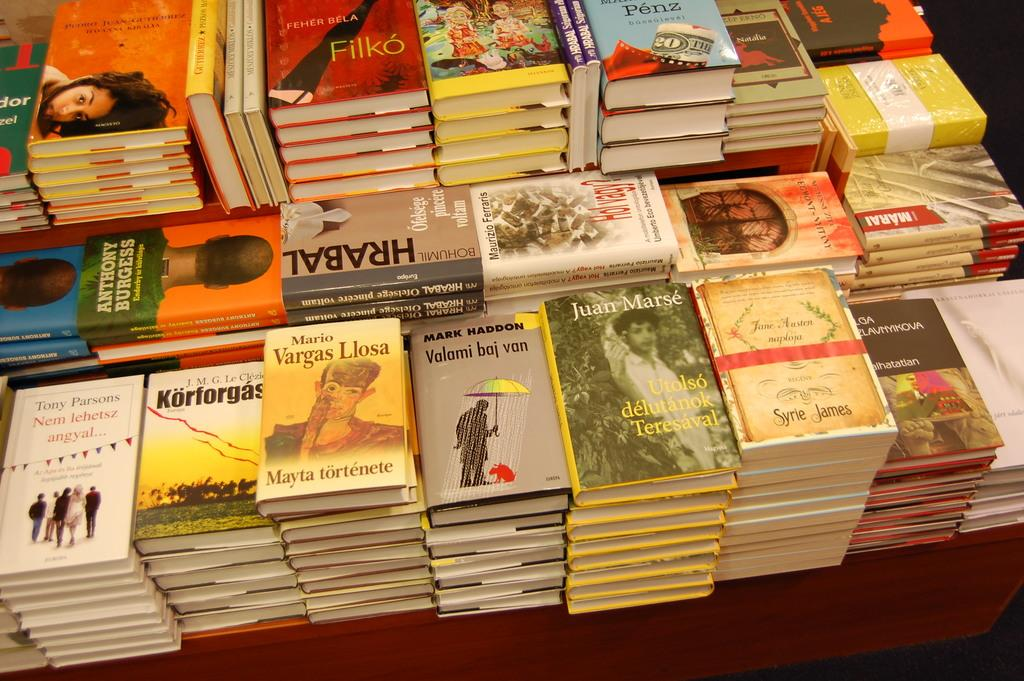<image>
Give a short and clear explanation of the subsequent image. Multiple stacks of books on a table, including one by Vargas Llosa 